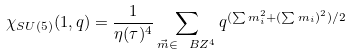<formula> <loc_0><loc_0><loc_500><loc_500>\chi _ { S U ( 5 ) } ( { 1 } , q ) = \frac { 1 } { \eta ( \tau ) ^ { 4 } } \sum _ { \vec { m } \in \ B Z ^ { 4 } } q ^ { ( \sum m _ { i } ^ { 2 } + ( \sum m _ { i } ) ^ { 2 } ) / 2 }</formula> 